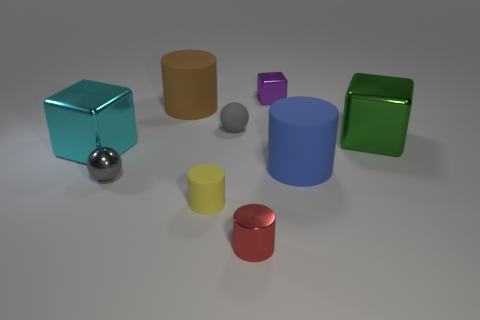Add 1 tiny gray matte objects. How many objects exist? 10 Subtract all blocks. How many objects are left? 6 Add 5 tiny gray things. How many tiny gray things are left? 7 Add 7 small shiny blocks. How many small shiny blocks exist? 8 Subtract 1 green cubes. How many objects are left? 8 Subtract all big yellow metallic things. Subtract all small gray matte spheres. How many objects are left? 8 